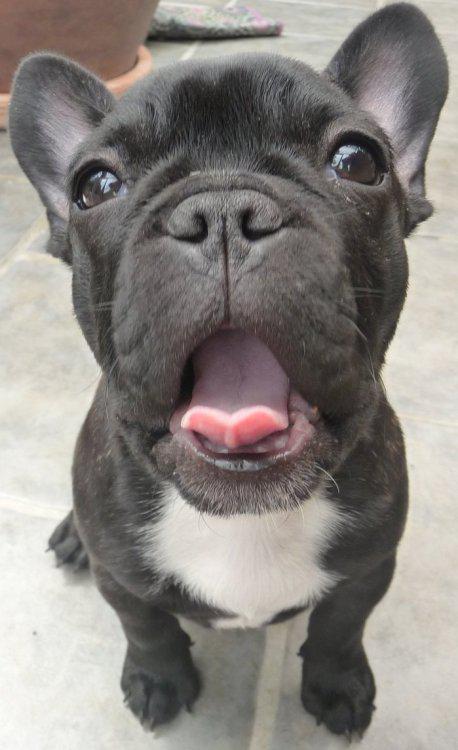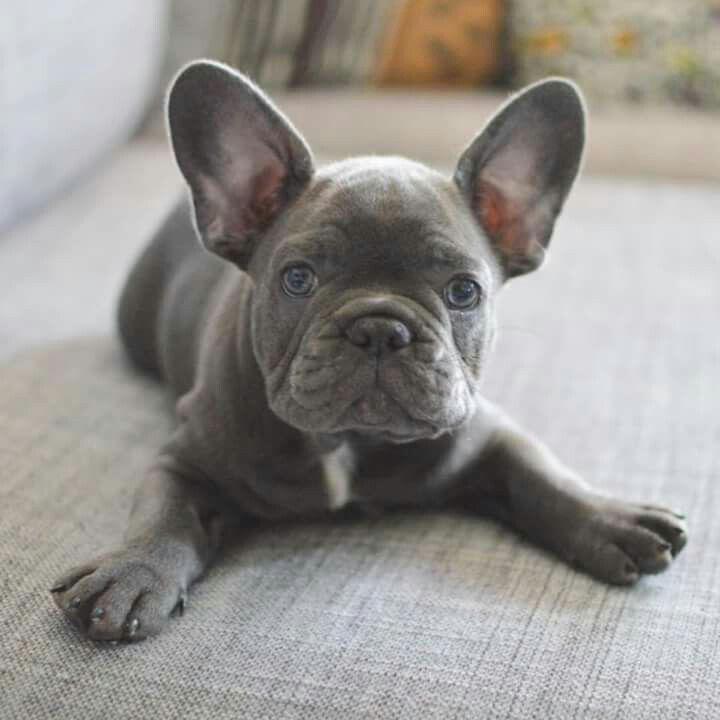The first image is the image on the left, the second image is the image on the right. Considering the images on both sides, is "Left image features one sitting puppy with dark gray fur and a white chest marking." valid? Answer yes or no. Yes. 